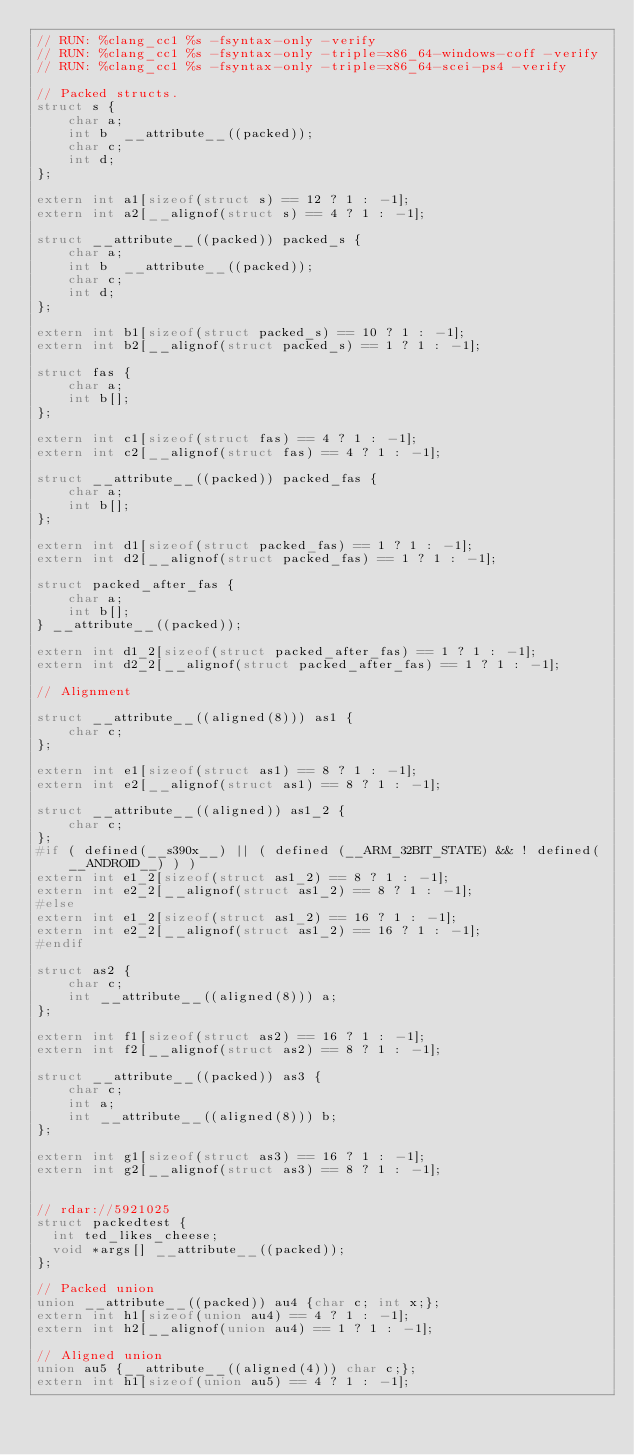<code> <loc_0><loc_0><loc_500><loc_500><_C_>// RUN: %clang_cc1 %s -fsyntax-only -verify
// RUN: %clang_cc1 %s -fsyntax-only -triple=x86_64-windows-coff -verify
// RUN: %clang_cc1 %s -fsyntax-only -triple=x86_64-scei-ps4 -verify

// Packed structs.
struct s {
    char a;
    int b  __attribute__((packed));
    char c;
    int d;
};

extern int a1[sizeof(struct s) == 12 ? 1 : -1];
extern int a2[__alignof(struct s) == 4 ? 1 : -1];

struct __attribute__((packed)) packed_s {
    char a;
    int b  __attribute__((packed));
    char c;
    int d;
};

extern int b1[sizeof(struct packed_s) == 10 ? 1 : -1];
extern int b2[__alignof(struct packed_s) == 1 ? 1 : -1];

struct fas {
    char a;
    int b[];
};

extern int c1[sizeof(struct fas) == 4 ? 1 : -1];
extern int c2[__alignof(struct fas) == 4 ? 1 : -1];

struct __attribute__((packed)) packed_fas {
    char a;
    int b[];
};

extern int d1[sizeof(struct packed_fas) == 1 ? 1 : -1];
extern int d2[__alignof(struct packed_fas) == 1 ? 1 : -1];

struct packed_after_fas {
    char a;
    int b[];
} __attribute__((packed));

extern int d1_2[sizeof(struct packed_after_fas) == 1 ? 1 : -1];
extern int d2_2[__alignof(struct packed_after_fas) == 1 ? 1 : -1];

// Alignment

struct __attribute__((aligned(8))) as1 {
    char c;
};

extern int e1[sizeof(struct as1) == 8 ? 1 : -1];
extern int e2[__alignof(struct as1) == 8 ? 1 : -1];

struct __attribute__((aligned)) as1_2 {
    char c;
};
#if ( defined(__s390x__) || ( defined (__ARM_32BIT_STATE) && ! defined(__ANDROID__) ) )
extern int e1_2[sizeof(struct as1_2) == 8 ? 1 : -1];
extern int e2_2[__alignof(struct as1_2) == 8 ? 1 : -1];
#else
extern int e1_2[sizeof(struct as1_2) == 16 ? 1 : -1];
extern int e2_2[__alignof(struct as1_2) == 16 ? 1 : -1];
#endif

struct as2 {
    char c;
    int __attribute__((aligned(8))) a;
};

extern int f1[sizeof(struct as2) == 16 ? 1 : -1];
extern int f2[__alignof(struct as2) == 8 ? 1 : -1];

struct __attribute__((packed)) as3 {
    char c;
    int a;
    int __attribute__((aligned(8))) b;
};

extern int g1[sizeof(struct as3) == 16 ? 1 : -1];
extern int g2[__alignof(struct as3) == 8 ? 1 : -1];


// rdar://5921025
struct packedtest {
  int ted_likes_cheese;
  void *args[] __attribute__((packed));
};

// Packed union
union __attribute__((packed)) au4 {char c; int x;};
extern int h1[sizeof(union au4) == 4 ? 1 : -1];
extern int h2[__alignof(union au4) == 1 ? 1 : -1];

// Aligned union
union au5 {__attribute__((aligned(4))) char c;};
extern int h1[sizeof(union au5) == 4 ? 1 : -1];</code> 